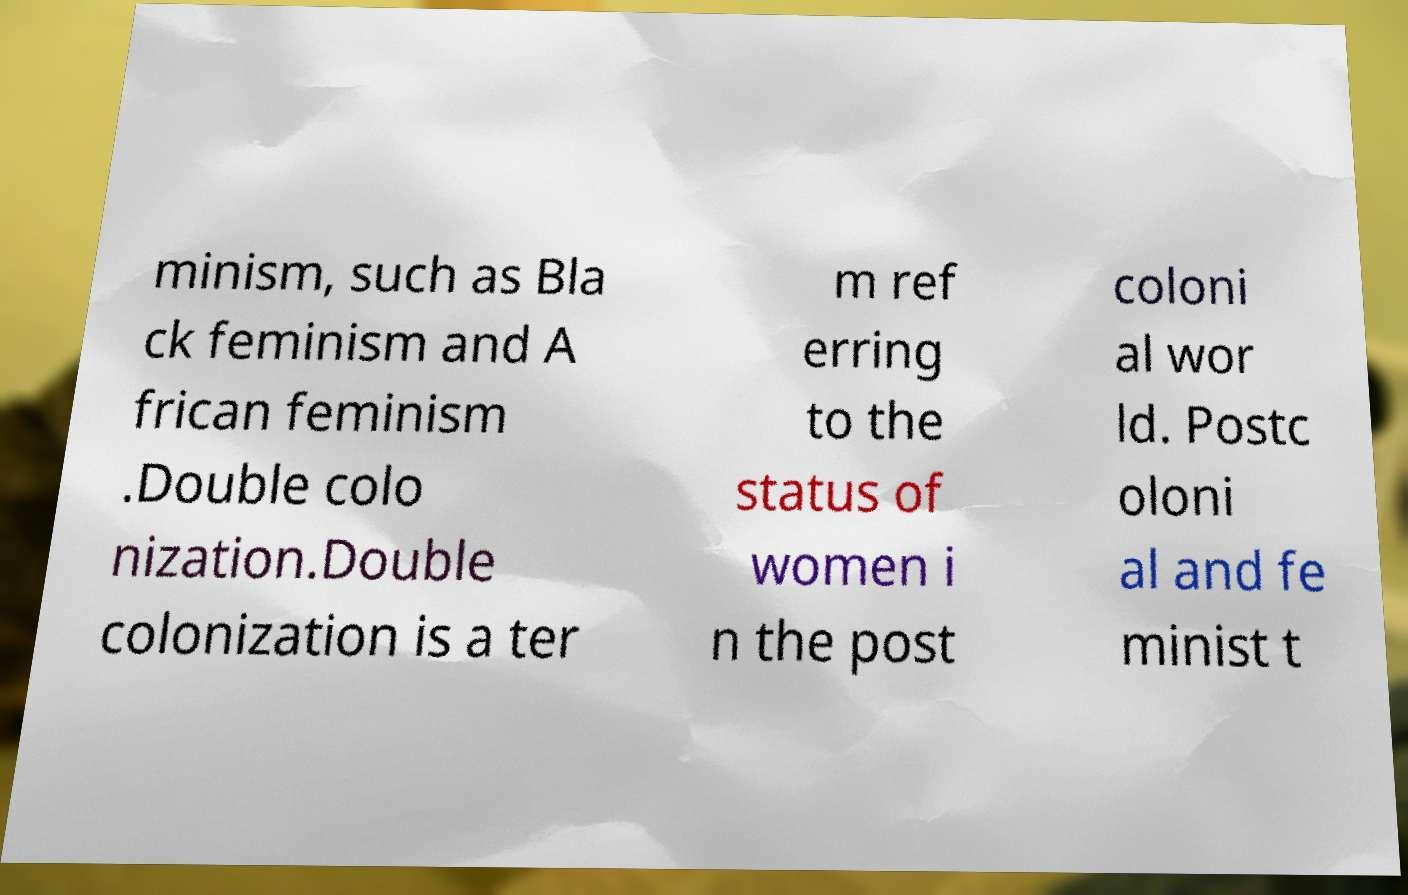Could you assist in decoding the text presented in this image and type it out clearly? minism, such as Bla ck feminism and A frican feminism .Double colo nization.Double colonization is a ter m ref erring to the status of women i n the post coloni al wor ld. Postc oloni al and fe minist t 